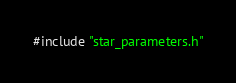Convert code to text. <code><loc_0><loc_0><loc_500><loc_500><_C++_>#include "star_parameters.h"
</code> 